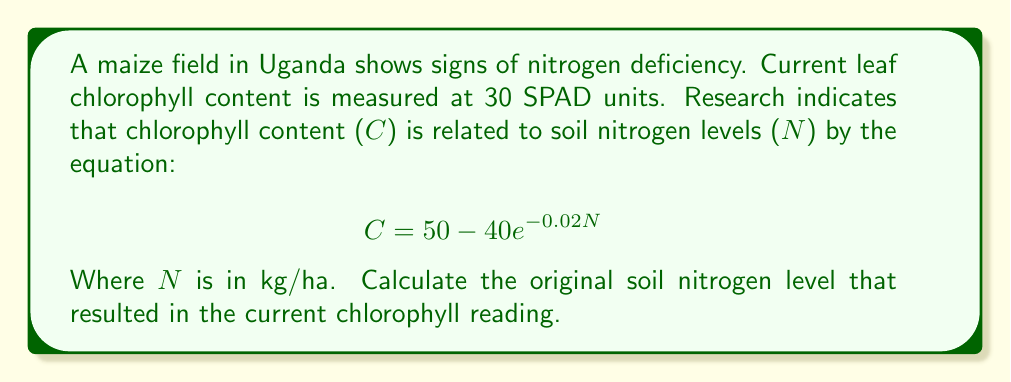Provide a solution to this math problem. To solve this inverse problem, we need to work backwards from the given chlorophyll content to determine the original soil nitrogen level. Let's approach this step-by-step:

1) We're given that the current chlorophyll content (C) is 30 SPAD units.

2) The equation relating chlorophyll content (C) to soil nitrogen levels (N) is:
   $$ C = 50 - 40e^{-0.02N} $$

3) Let's substitute the known value of C:
   $$ 30 = 50 - 40e^{-0.02N} $$

4) Subtract 50 from both sides:
   $$ -20 = -40e^{-0.02N} $$

5) Divide both sides by -40:
   $$ 0.5 = e^{-0.02N} $$

6) Take the natural logarithm of both sides:
   $$ \ln(0.5) = -0.02N $$

7) Solve for N:
   $$ N = \frac{\ln(0.5)}{-0.02} $$

8) Calculate the value:
   $$ N = \frac{-0.69315}{-0.02} \approx 34.66 $$

Therefore, the original soil nitrogen level was approximately 34.66 kg/ha.
Answer: 34.66 kg/ha 